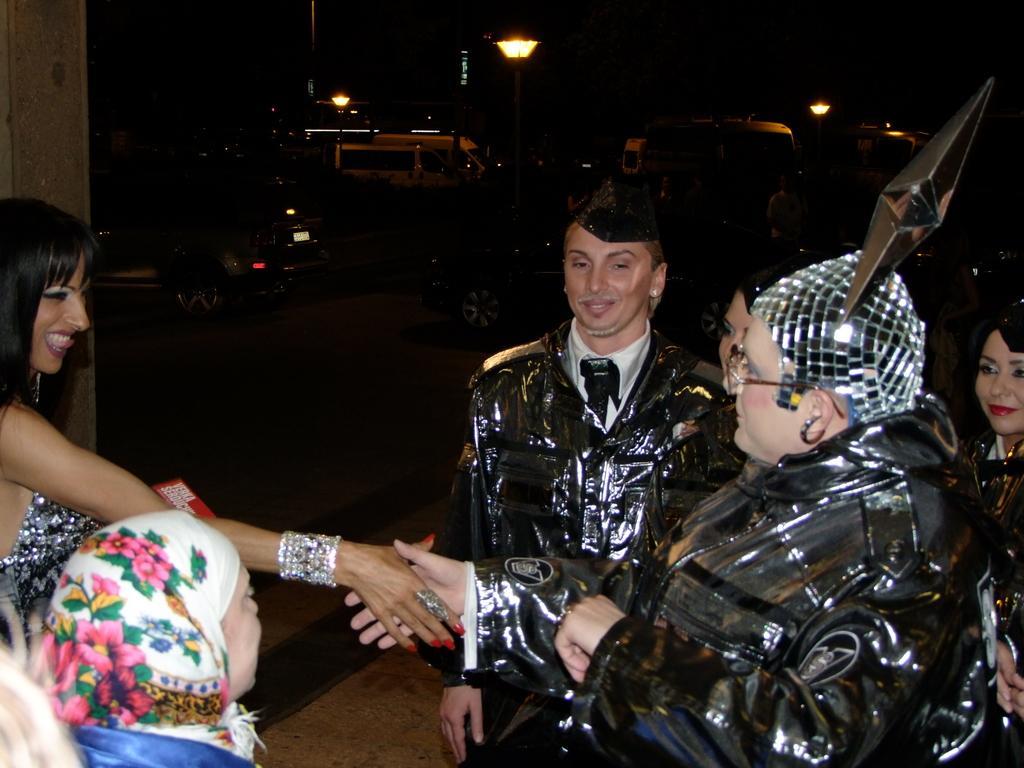How would you summarize this image in a sentence or two? In this image we can see a few people and among them two people are shaking their hands and in the background, we can see some vehicles and street lights. 